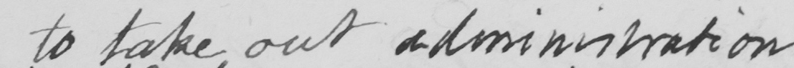Please transcribe the handwritten text in this image. to take out administration 